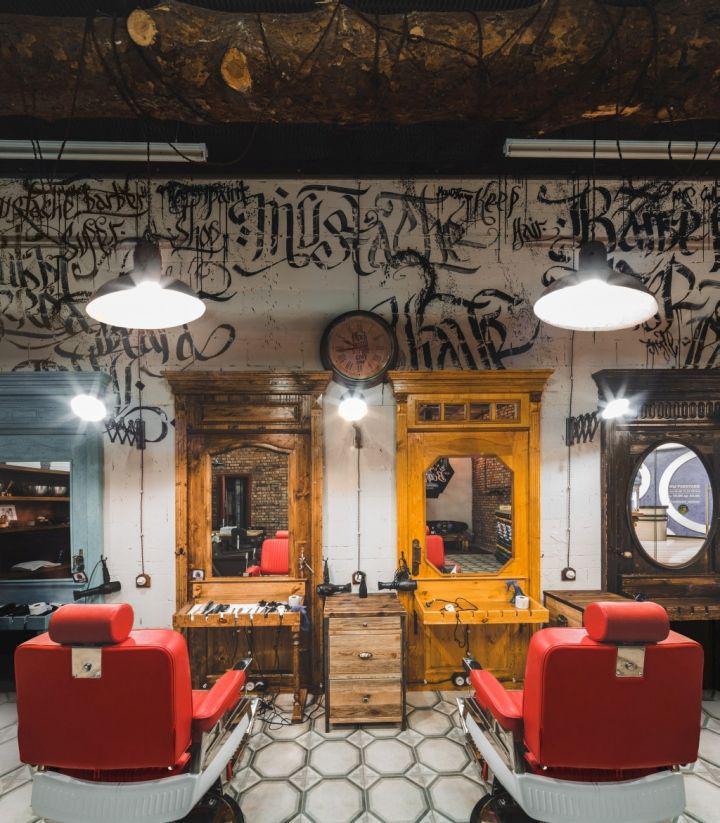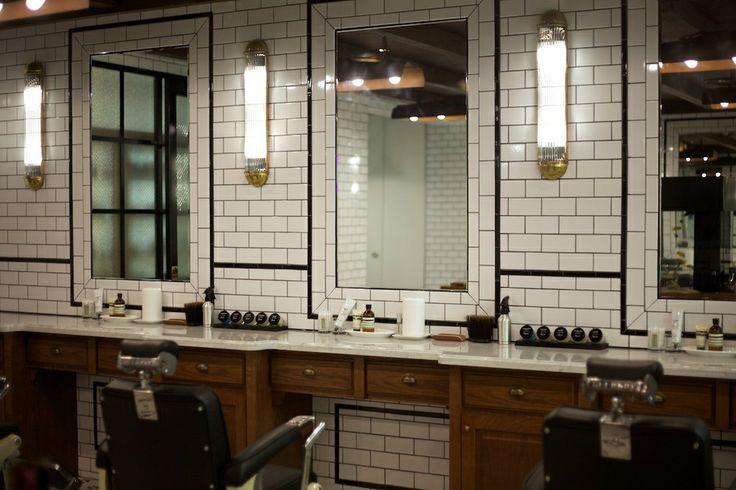The first image is the image on the left, the second image is the image on the right. Analyze the images presented: Is the assertion "One image is the interior of a barber shop and one image is the exterior of a barber shop" valid? Answer yes or no. No. The first image is the image on the left, the second image is the image on the right. For the images shown, is this caption "There is a barber pole in one of the iamges." true? Answer yes or no. No. 